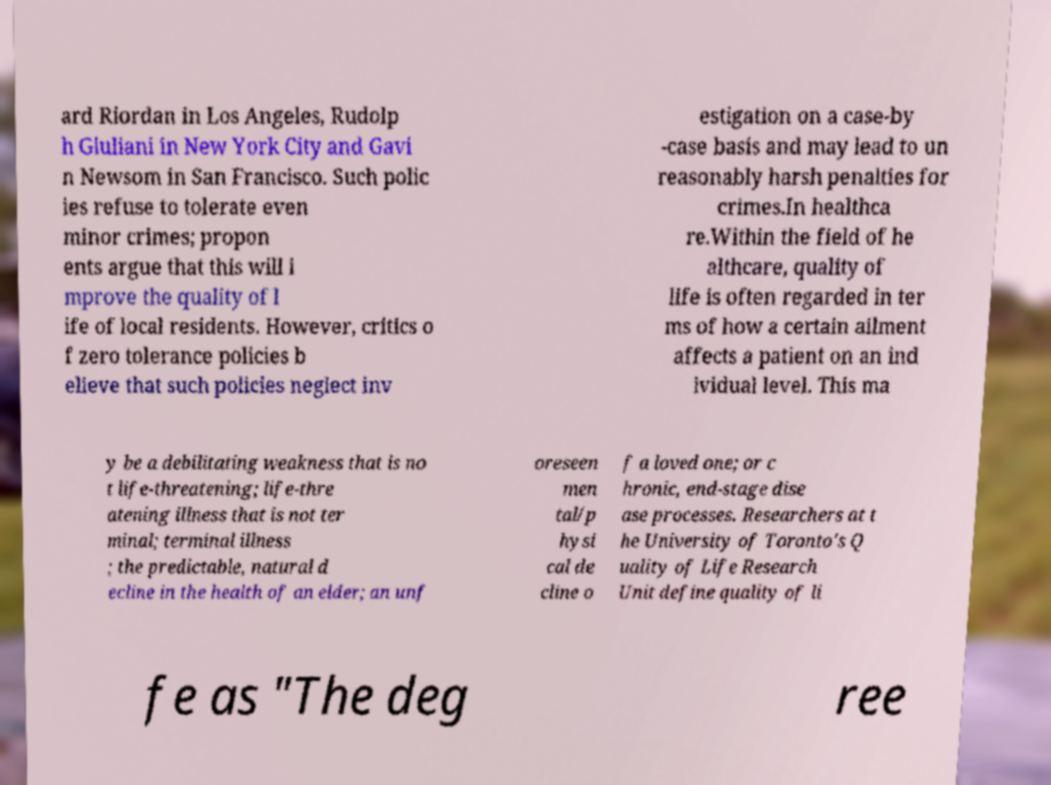Please identify and transcribe the text found in this image. ard Riordan in Los Angeles, Rudolp h Giuliani in New York City and Gavi n Newsom in San Francisco. Such polic ies refuse to tolerate even minor crimes; propon ents argue that this will i mprove the quality of l ife of local residents. However, critics o f zero tolerance policies b elieve that such policies neglect inv estigation on a case-by -case basis and may lead to un reasonably harsh penalties for crimes.In healthca re.Within the field of he althcare, quality of life is often regarded in ter ms of how a certain ailment affects a patient on an ind ividual level. This ma y be a debilitating weakness that is no t life-threatening; life-thre atening illness that is not ter minal; terminal illness ; the predictable, natural d ecline in the health of an elder; an unf oreseen men tal/p hysi cal de cline o f a loved one; or c hronic, end-stage dise ase processes. Researchers at t he University of Toronto's Q uality of Life Research Unit define quality of li fe as "The deg ree 